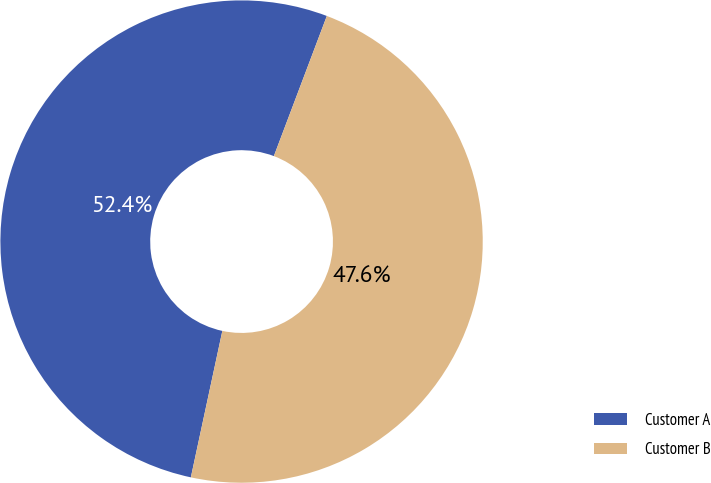Convert chart to OTSL. <chart><loc_0><loc_0><loc_500><loc_500><pie_chart><fcel>Customer A<fcel>Customer B<nl><fcel>52.38%<fcel>47.62%<nl></chart> 